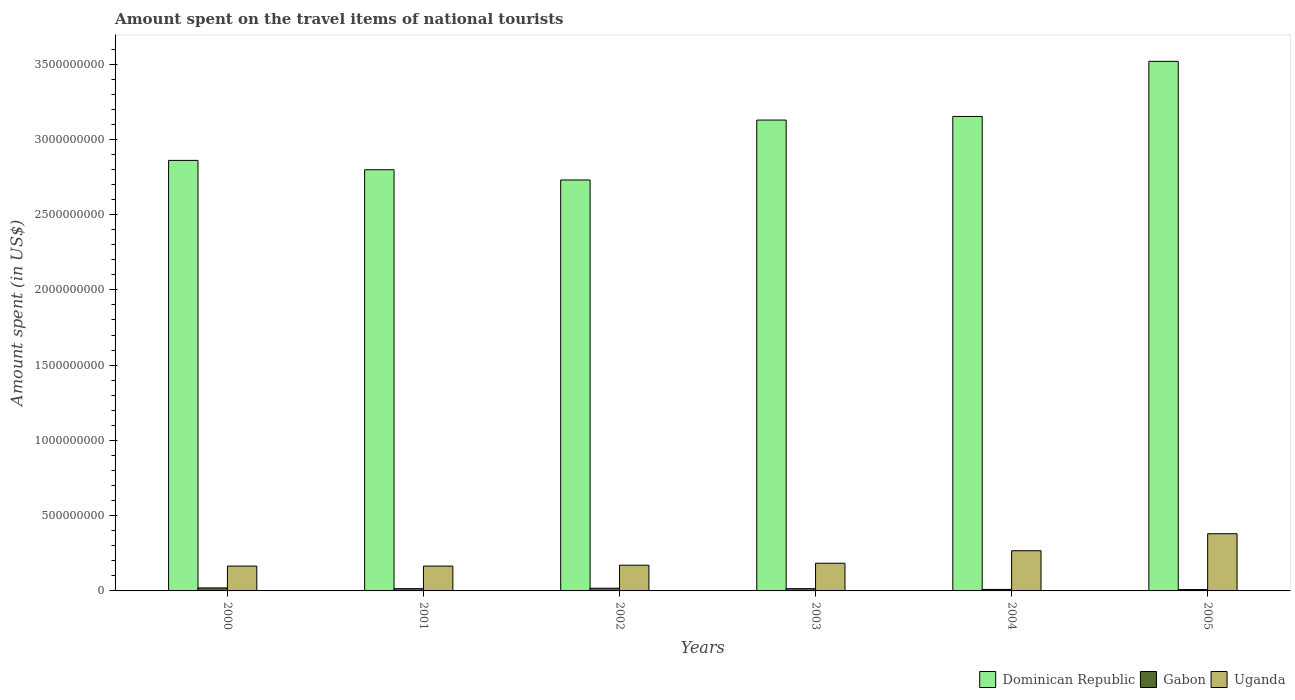How many different coloured bars are there?
Your answer should be compact. 3. How many groups of bars are there?
Your response must be concise. 6. Are the number of bars per tick equal to the number of legend labels?
Give a very brief answer. Yes. Are the number of bars on each tick of the X-axis equal?
Offer a terse response. Yes. How many bars are there on the 2nd tick from the right?
Offer a terse response. 3. What is the label of the 4th group of bars from the left?
Give a very brief answer. 2003. What is the amount spent on the travel items of national tourists in Uganda in 2003?
Give a very brief answer. 1.84e+08. Across all years, what is the maximum amount spent on the travel items of national tourists in Dominican Republic?
Your answer should be very brief. 3.52e+09. Across all years, what is the minimum amount spent on the travel items of national tourists in Dominican Republic?
Provide a short and direct response. 2.73e+09. In which year was the amount spent on the travel items of national tourists in Gabon maximum?
Make the answer very short. 2000. In which year was the amount spent on the travel items of national tourists in Dominican Republic minimum?
Keep it short and to the point. 2002. What is the total amount spent on the travel items of national tourists in Gabon in the graph?
Your response must be concise. 8.70e+07. What is the difference between the amount spent on the travel items of national tourists in Uganda in 2000 and that in 2002?
Give a very brief answer. -6.00e+06. What is the difference between the amount spent on the travel items of national tourists in Dominican Republic in 2003 and the amount spent on the travel items of national tourists in Uganda in 2002?
Your response must be concise. 2.96e+09. What is the average amount spent on the travel items of national tourists in Dominican Republic per year?
Your answer should be very brief. 3.03e+09. In the year 2002, what is the difference between the amount spent on the travel items of national tourists in Dominican Republic and amount spent on the travel items of national tourists in Uganda?
Give a very brief answer. 2.56e+09. What is the difference between the highest and the second highest amount spent on the travel items of national tourists in Gabon?
Ensure brevity in your answer.  2.00e+06. What is the difference between the highest and the lowest amount spent on the travel items of national tourists in Uganda?
Offer a very short reply. 2.15e+08. What does the 2nd bar from the left in 2002 represents?
Provide a short and direct response. Gabon. What does the 3rd bar from the right in 2000 represents?
Offer a very short reply. Dominican Republic. Are all the bars in the graph horizontal?
Ensure brevity in your answer.  No. What is the difference between two consecutive major ticks on the Y-axis?
Keep it short and to the point. 5.00e+08. Does the graph contain any zero values?
Keep it short and to the point. No. Where does the legend appear in the graph?
Provide a succinct answer. Bottom right. How are the legend labels stacked?
Give a very brief answer. Horizontal. What is the title of the graph?
Provide a short and direct response. Amount spent on the travel items of national tourists. Does "Thailand" appear as one of the legend labels in the graph?
Provide a succinct answer. No. What is the label or title of the X-axis?
Your answer should be compact. Years. What is the label or title of the Y-axis?
Keep it short and to the point. Amount spent (in US$). What is the Amount spent (in US$) of Dominican Republic in 2000?
Keep it short and to the point. 2.86e+09. What is the Amount spent (in US$) in Uganda in 2000?
Ensure brevity in your answer.  1.65e+08. What is the Amount spent (in US$) of Dominican Republic in 2001?
Give a very brief answer. 2.80e+09. What is the Amount spent (in US$) in Gabon in 2001?
Provide a short and direct response. 1.50e+07. What is the Amount spent (in US$) of Uganda in 2001?
Keep it short and to the point. 1.65e+08. What is the Amount spent (in US$) of Dominican Republic in 2002?
Make the answer very short. 2.73e+09. What is the Amount spent (in US$) in Gabon in 2002?
Your answer should be very brief. 1.80e+07. What is the Amount spent (in US$) in Uganda in 2002?
Ensure brevity in your answer.  1.71e+08. What is the Amount spent (in US$) of Dominican Republic in 2003?
Your response must be concise. 3.13e+09. What is the Amount spent (in US$) of Gabon in 2003?
Your answer should be compact. 1.50e+07. What is the Amount spent (in US$) of Uganda in 2003?
Your answer should be compact. 1.84e+08. What is the Amount spent (in US$) in Dominican Republic in 2004?
Your answer should be compact. 3.15e+09. What is the Amount spent (in US$) in Uganda in 2004?
Your answer should be compact. 2.67e+08. What is the Amount spent (in US$) of Dominican Republic in 2005?
Give a very brief answer. 3.52e+09. What is the Amount spent (in US$) of Gabon in 2005?
Keep it short and to the point. 9.00e+06. What is the Amount spent (in US$) of Uganda in 2005?
Provide a short and direct response. 3.80e+08. Across all years, what is the maximum Amount spent (in US$) in Dominican Republic?
Your answer should be very brief. 3.52e+09. Across all years, what is the maximum Amount spent (in US$) in Gabon?
Offer a very short reply. 2.00e+07. Across all years, what is the maximum Amount spent (in US$) in Uganda?
Offer a very short reply. 3.80e+08. Across all years, what is the minimum Amount spent (in US$) in Dominican Republic?
Your response must be concise. 2.73e+09. Across all years, what is the minimum Amount spent (in US$) of Gabon?
Provide a short and direct response. 9.00e+06. Across all years, what is the minimum Amount spent (in US$) of Uganda?
Keep it short and to the point. 1.65e+08. What is the total Amount spent (in US$) in Dominican Republic in the graph?
Offer a terse response. 1.82e+1. What is the total Amount spent (in US$) of Gabon in the graph?
Ensure brevity in your answer.  8.70e+07. What is the total Amount spent (in US$) in Uganda in the graph?
Provide a succinct answer. 1.33e+09. What is the difference between the Amount spent (in US$) in Dominican Republic in 2000 and that in 2001?
Ensure brevity in your answer.  6.20e+07. What is the difference between the Amount spent (in US$) in Uganda in 2000 and that in 2001?
Ensure brevity in your answer.  0. What is the difference between the Amount spent (in US$) in Dominican Republic in 2000 and that in 2002?
Give a very brief answer. 1.30e+08. What is the difference between the Amount spent (in US$) in Gabon in 2000 and that in 2002?
Make the answer very short. 2.00e+06. What is the difference between the Amount spent (in US$) in Uganda in 2000 and that in 2002?
Make the answer very short. -6.00e+06. What is the difference between the Amount spent (in US$) of Dominican Republic in 2000 and that in 2003?
Keep it short and to the point. -2.68e+08. What is the difference between the Amount spent (in US$) in Gabon in 2000 and that in 2003?
Your response must be concise. 5.00e+06. What is the difference between the Amount spent (in US$) of Uganda in 2000 and that in 2003?
Give a very brief answer. -1.90e+07. What is the difference between the Amount spent (in US$) in Dominican Republic in 2000 and that in 2004?
Your answer should be very brief. -2.92e+08. What is the difference between the Amount spent (in US$) of Gabon in 2000 and that in 2004?
Make the answer very short. 1.00e+07. What is the difference between the Amount spent (in US$) in Uganda in 2000 and that in 2004?
Ensure brevity in your answer.  -1.02e+08. What is the difference between the Amount spent (in US$) in Dominican Republic in 2000 and that in 2005?
Provide a short and direct response. -6.58e+08. What is the difference between the Amount spent (in US$) of Gabon in 2000 and that in 2005?
Your answer should be very brief. 1.10e+07. What is the difference between the Amount spent (in US$) of Uganda in 2000 and that in 2005?
Your answer should be compact. -2.15e+08. What is the difference between the Amount spent (in US$) in Dominican Republic in 2001 and that in 2002?
Your answer should be very brief. 6.80e+07. What is the difference between the Amount spent (in US$) of Uganda in 2001 and that in 2002?
Keep it short and to the point. -6.00e+06. What is the difference between the Amount spent (in US$) in Dominican Republic in 2001 and that in 2003?
Your answer should be very brief. -3.30e+08. What is the difference between the Amount spent (in US$) of Uganda in 2001 and that in 2003?
Provide a short and direct response. -1.90e+07. What is the difference between the Amount spent (in US$) of Dominican Republic in 2001 and that in 2004?
Offer a very short reply. -3.54e+08. What is the difference between the Amount spent (in US$) in Uganda in 2001 and that in 2004?
Make the answer very short. -1.02e+08. What is the difference between the Amount spent (in US$) of Dominican Republic in 2001 and that in 2005?
Your answer should be compact. -7.20e+08. What is the difference between the Amount spent (in US$) in Uganda in 2001 and that in 2005?
Make the answer very short. -2.15e+08. What is the difference between the Amount spent (in US$) of Dominican Republic in 2002 and that in 2003?
Provide a short and direct response. -3.98e+08. What is the difference between the Amount spent (in US$) in Gabon in 2002 and that in 2003?
Keep it short and to the point. 3.00e+06. What is the difference between the Amount spent (in US$) of Uganda in 2002 and that in 2003?
Your response must be concise. -1.30e+07. What is the difference between the Amount spent (in US$) of Dominican Republic in 2002 and that in 2004?
Keep it short and to the point. -4.22e+08. What is the difference between the Amount spent (in US$) in Uganda in 2002 and that in 2004?
Keep it short and to the point. -9.60e+07. What is the difference between the Amount spent (in US$) of Dominican Republic in 2002 and that in 2005?
Provide a succinct answer. -7.88e+08. What is the difference between the Amount spent (in US$) in Gabon in 2002 and that in 2005?
Offer a very short reply. 9.00e+06. What is the difference between the Amount spent (in US$) of Uganda in 2002 and that in 2005?
Offer a terse response. -2.09e+08. What is the difference between the Amount spent (in US$) in Dominican Republic in 2003 and that in 2004?
Ensure brevity in your answer.  -2.40e+07. What is the difference between the Amount spent (in US$) in Uganda in 2003 and that in 2004?
Offer a terse response. -8.30e+07. What is the difference between the Amount spent (in US$) in Dominican Republic in 2003 and that in 2005?
Make the answer very short. -3.90e+08. What is the difference between the Amount spent (in US$) in Gabon in 2003 and that in 2005?
Ensure brevity in your answer.  6.00e+06. What is the difference between the Amount spent (in US$) of Uganda in 2003 and that in 2005?
Keep it short and to the point. -1.96e+08. What is the difference between the Amount spent (in US$) in Dominican Republic in 2004 and that in 2005?
Provide a succinct answer. -3.66e+08. What is the difference between the Amount spent (in US$) in Uganda in 2004 and that in 2005?
Your answer should be compact. -1.13e+08. What is the difference between the Amount spent (in US$) in Dominican Republic in 2000 and the Amount spent (in US$) in Gabon in 2001?
Provide a succinct answer. 2.84e+09. What is the difference between the Amount spent (in US$) in Dominican Republic in 2000 and the Amount spent (in US$) in Uganda in 2001?
Offer a terse response. 2.70e+09. What is the difference between the Amount spent (in US$) of Gabon in 2000 and the Amount spent (in US$) of Uganda in 2001?
Your response must be concise. -1.45e+08. What is the difference between the Amount spent (in US$) of Dominican Republic in 2000 and the Amount spent (in US$) of Gabon in 2002?
Offer a very short reply. 2.84e+09. What is the difference between the Amount spent (in US$) of Dominican Republic in 2000 and the Amount spent (in US$) of Uganda in 2002?
Your response must be concise. 2.69e+09. What is the difference between the Amount spent (in US$) of Gabon in 2000 and the Amount spent (in US$) of Uganda in 2002?
Ensure brevity in your answer.  -1.51e+08. What is the difference between the Amount spent (in US$) in Dominican Republic in 2000 and the Amount spent (in US$) in Gabon in 2003?
Your response must be concise. 2.84e+09. What is the difference between the Amount spent (in US$) in Dominican Republic in 2000 and the Amount spent (in US$) in Uganda in 2003?
Provide a short and direct response. 2.68e+09. What is the difference between the Amount spent (in US$) of Gabon in 2000 and the Amount spent (in US$) of Uganda in 2003?
Your answer should be very brief. -1.64e+08. What is the difference between the Amount spent (in US$) in Dominican Republic in 2000 and the Amount spent (in US$) in Gabon in 2004?
Your answer should be very brief. 2.85e+09. What is the difference between the Amount spent (in US$) in Dominican Republic in 2000 and the Amount spent (in US$) in Uganda in 2004?
Your answer should be compact. 2.59e+09. What is the difference between the Amount spent (in US$) of Gabon in 2000 and the Amount spent (in US$) of Uganda in 2004?
Keep it short and to the point. -2.47e+08. What is the difference between the Amount spent (in US$) of Dominican Republic in 2000 and the Amount spent (in US$) of Gabon in 2005?
Offer a very short reply. 2.85e+09. What is the difference between the Amount spent (in US$) in Dominican Republic in 2000 and the Amount spent (in US$) in Uganda in 2005?
Offer a very short reply. 2.48e+09. What is the difference between the Amount spent (in US$) in Gabon in 2000 and the Amount spent (in US$) in Uganda in 2005?
Keep it short and to the point. -3.60e+08. What is the difference between the Amount spent (in US$) of Dominican Republic in 2001 and the Amount spent (in US$) of Gabon in 2002?
Keep it short and to the point. 2.78e+09. What is the difference between the Amount spent (in US$) in Dominican Republic in 2001 and the Amount spent (in US$) in Uganda in 2002?
Your answer should be compact. 2.63e+09. What is the difference between the Amount spent (in US$) of Gabon in 2001 and the Amount spent (in US$) of Uganda in 2002?
Give a very brief answer. -1.56e+08. What is the difference between the Amount spent (in US$) of Dominican Republic in 2001 and the Amount spent (in US$) of Gabon in 2003?
Give a very brief answer. 2.78e+09. What is the difference between the Amount spent (in US$) of Dominican Republic in 2001 and the Amount spent (in US$) of Uganda in 2003?
Make the answer very short. 2.61e+09. What is the difference between the Amount spent (in US$) of Gabon in 2001 and the Amount spent (in US$) of Uganda in 2003?
Your answer should be very brief. -1.69e+08. What is the difference between the Amount spent (in US$) of Dominican Republic in 2001 and the Amount spent (in US$) of Gabon in 2004?
Make the answer very short. 2.79e+09. What is the difference between the Amount spent (in US$) in Dominican Republic in 2001 and the Amount spent (in US$) in Uganda in 2004?
Make the answer very short. 2.53e+09. What is the difference between the Amount spent (in US$) of Gabon in 2001 and the Amount spent (in US$) of Uganda in 2004?
Give a very brief answer. -2.52e+08. What is the difference between the Amount spent (in US$) of Dominican Republic in 2001 and the Amount spent (in US$) of Gabon in 2005?
Make the answer very short. 2.79e+09. What is the difference between the Amount spent (in US$) of Dominican Republic in 2001 and the Amount spent (in US$) of Uganda in 2005?
Offer a very short reply. 2.42e+09. What is the difference between the Amount spent (in US$) in Gabon in 2001 and the Amount spent (in US$) in Uganda in 2005?
Offer a terse response. -3.65e+08. What is the difference between the Amount spent (in US$) in Dominican Republic in 2002 and the Amount spent (in US$) in Gabon in 2003?
Provide a succinct answer. 2.72e+09. What is the difference between the Amount spent (in US$) of Dominican Republic in 2002 and the Amount spent (in US$) of Uganda in 2003?
Offer a terse response. 2.55e+09. What is the difference between the Amount spent (in US$) in Gabon in 2002 and the Amount spent (in US$) in Uganda in 2003?
Provide a succinct answer. -1.66e+08. What is the difference between the Amount spent (in US$) of Dominican Republic in 2002 and the Amount spent (in US$) of Gabon in 2004?
Ensure brevity in your answer.  2.72e+09. What is the difference between the Amount spent (in US$) of Dominican Republic in 2002 and the Amount spent (in US$) of Uganda in 2004?
Provide a succinct answer. 2.46e+09. What is the difference between the Amount spent (in US$) in Gabon in 2002 and the Amount spent (in US$) in Uganda in 2004?
Your answer should be very brief. -2.49e+08. What is the difference between the Amount spent (in US$) of Dominican Republic in 2002 and the Amount spent (in US$) of Gabon in 2005?
Keep it short and to the point. 2.72e+09. What is the difference between the Amount spent (in US$) of Dominican Republic in 2002 and the Amount spent (in US$) of Uganda in 2005?
Offer a terse response. 2.35e+09. What is the difference between the Amount spent (in US$) in Gabon in 2002 and the Amount spent (in US$) in Uganda in 2005?
Provide a short and direct response. -3.62e+08. What is the difference between the Amount spent (in US$) of Dominican Republic in 2003 and the Amount spent (in US$) of Gabon in 2004?
Give a very brief answer. 3.12e+09. What is the difference between the Amount spent (in US$) in Dominican Republic in 2003 and the Amount spent (in US$) in Uganda in 2004?
Provide a short and direct response. 2.86e+09. What is the difference between the Amount spent (in US$) in Gabon in 2003 and the Amount spent (in US$) in Uganda in 2004?
Ensure brevity in your answer.  -2.52e+08. What is the difference between the Amount spent (in US$) of Dominican Republic in 2003 and the Amount spent (in US$) of Gabon in 2005?
Provide a short and direct response. 3.12e+09. What is the difference between the Amount spent (in US$) of Dominican Republic in 2003 and the Amount spent (in US$) of Uganda in 2005?
Your answer should be compact. 2.75e+09. What is the difference between the Amount spent (in US$) of Gabon in 2003 and the Amount spent (in US$) of Uganda in 2005?
Make the answer very short. -3.65e+08. What is the difference between the Amount spent (in US$) of Dominican Republic in 2004 and the Amount spent (in US$) of Gabon in 2005?
Make the answer very short. 3.14e+09. What is the difference between the Amount spent (in US$) in Dominican Republic in 2004 and the Amount spent (in US$) in Uganda in 2005?
Give a very brief answer. 2.77e+09. What is the difference between the Amount spent (in US$) in Gabon in 2004 and the Amount spent (in US$) in Uganda in 2005?
Your answer should be very brief. -3.70e+08. What is the average Amount spent (in US$) in Dominican Republic per year?
Your response must be concise. 3.03e+09. What is the average Amount spent (in US$) of Gabon per year?
Your response must be concise. 1.45e+07. What is the average Amount spent (in US$) in Uganda per year?
Your response must be concise. 2.22e+08. In the year 2000, what is the difference between the Amount spent (in US$) of Dominican Republic and Amount spent (in US$) of Gabon?
Ensure brevity in your answer.  2.84e+09. In the year 2000, what is the difference between the Amount spent (in US$) in Dominican Republic and Amount spent (in US$) in Uganda?
Make the answer very short. 2.70e+09. In the year 2000, what is the difference between the Amount spent (in US$) of Gabon and Amount spent (in US$) of Uganda?
Your answer should be very brief. -1.45e+08. In the year 2001, what is the difference between the Amount spent (in US$) of Dominican Republic and Amount spent (in US$) of Gabon?
Provide a short and direct response. 2.78e+09. In the year 2001, what is the difference between the Amount spent (in US$) in Dominican Republic and Amount spent (in US$) in Uganda?
Give a very brief answer. 2.63e+09. In the year 2001, what is the difference between the Amount spent (in US$) of Gabon and Amount spent (in US$) of Uganda?
Your response must be concise. -1.50e+08. In the year 2002, what is the difference between the Amount spent (in US$) of Dominican Republic and Amount spent (in US$) of Gabon?
Your response must be concise. 2.71e+09. In the year 2002, what is the difference between the Amount spent (in US$) in Dominican Republic and Amount spent (in US$) in Uganda?
Provide a succinct answer. 2.56e+09. In the year 2002, what is the difference between the Amount spent (in US$) of Gabon and Amount spent (in US$) of Uganda?
Your answer should be compact. -1.53e+08. In the year 2003, what is the difference between the Amount spent (in US$) of Dominican Republic and Amount spent (in US$) of Gabon?
Your answer should be compact. 3.11e+09. In the year 2003, what is the difference between the Amount spent (in US$) in Dominican Republic and Amount spent (in US$) in Uganda?
Offer a terse response. 2.94e+09. In the year 2003, what is the difference between the Amount spent (in US$) of Gabon and Amount spent (in US$) of Uganda?
Provide a short and direct response. -1.69e+08. In the year 2004, what is the difference between the Amount spent (in US$) in Dominican Republic and Amount spent (in US$) in Gabon?
Your response must be concise. 3.14e+09. In the year 2004, what is the difference between the Amount spent (in US$) in Dominican Republic and Amount spent (in US$) in Uganda?
Offer a terse response. 2.88e+09. In the year 2004, what is the difference between the Amount spent (in US$) of Gabon and Amount spent (in US$) of Uganda?
Your answer should be very brief. -2.57e+08. In the year 2005, what is the difference between the Amount spent (in US$) in Dominican Republic and Amount spent (in US$) in Gabon?
Give a very brief answer. 3.51e+09. In the year 2005, what is the difference between the Amount spent (in US$) of Dominican Republic and Amount spent (in US$) of Uganda?
Ensure brevity in your answer.  3.14e+09. In the year 2005, what is the difference between the Amount spent (in US$) of Gabon and Amount spent (in US$) of Uganda?
Keep it short and to the point. -3.71e+08. What is the ratio of the Amount spent (in US$) of Dominican Republic in 2000 to that in 2001?
Keep it short and to the point. 1.02. What is the ratio of the Amount spent (in US$) in Uganda in 2000 to that in 2001?
Offer a very short reply. 1. What is the ratio of the Amount spent (in US$) of Dominican Republic in 2000 to that in 2002?
Keep it short and to the point. 1.05. What is the ratio of the Amount spent (in US$) of Uganda in 2000 to that in 2002?
Provide a succinct answer. 0.96. What is the ratio of the Amount spent (in US$) in Dominican Republic in 2000 to that in 2003?
Your response must be concise. 0.91. What is the ratio of the Amount spent (in US$) of Uganda in 2000 to that in 2003?
Provide a short and direct response. 0.9. What is the ratio of the Amount spent (in US$) of Dominican Republic in 2000 to that in 2004?
Make the answer very short. 0.91. What is the ratio of the Amount spent (in US$) in Gabon in 2000 to that in 2004?
Make the answer very short. 2. What is the ratio of the Amount spent (in US$) in Uganda in 2000 to that in 2004?
Provide a short and direct response. 0.62. What is the ratio of the Amount spent (in US$) of Dominican Republic in 2000 to that in 2005?
Your answer should be very brief. 0.81. What is the ratio of the Amount spent (in US$) of Gabon in 2000 to that in 2005?
Make the answer very short. 2.22. What is the ratio of the Amount spent (in US$) in Uganda in 2000 to that in 2005?
Give a very brief answer. 0.43. What is the ratio of the Amount spent (in US$) in Dominican Republic in 2001 to that in 2002?
Your answer should be compact. 1.02. What is the ratio of the Amount spent (in US$) in Gabon in 2001 to that in 2002?
Offer a terse response. 0.83. What is the ratio of the Amount spent (in US$) in Uganda in 2001 to that in 2002?
Offer a terse response. 0.96. What is the ratio of the Amount spent (in US$) in Dominican Republic in 2001 to that in 2003?
Your response must be concise. 0.89. What is the ratio of the Amount spent (in US$) of Gabon in 2001 to that in 2003?
Keep it short and to the point. 1. What is the ratio of the Amount spent (in US$) of Uganda in 2001 to that in 2003?
Keep it short and to the point. 0.9. What is the ratio of the Amount spent (in US$) in Dominican Republic in 2001 to that in 2004?
Keep it short and to the point. 0.89. What is the ratio of the Amount spent (in US$) in Uganda in 2001 to that in 2004?
Offer a terse response. 0.62. What is the ratio of the Amount spent (in US$) of Dominican Republic in 2001 to that in 2005?
Provide a short and direct response. 0.8. What is the ratio of the Amount spent (in US$) of Uganda in 2001 to that in 2005?
Your response must be concise. 0.43. What is the ratio of the Amount spent (in US$) in Dominican Republic in 2002 to that in 2003?
Offer a very short reply. 0.87. What is the ratio of the Amount spent (in US$) in Gabon in 2002 to that in 2003?
Your answer should be compact. 1.2. What is the ratio of the Amount spent (in US$) in Uganda in 2002 to that in 2003?
Your answer should be compact. 0.93. What is the ratio of the Amount spent (in US$) of Dominican Republic in 2002 to that in 2004?
Provide a succinct answer. 0.87. What is the ratio of the Amount spent (in US$) of Uganda in 2002 to that in 2004?
Provide a succinct answer. 0.64. What is the ratio of the Amount spent (in US$) in Dominican Republic in 2002 to that in 2005?
Offer a very short reply. 0.78. What is the ratio of the Amount spent (in US$) of Gabon in 2002 to that in 2005?
Provide a short and direct response. 2. What is the ratio of the Amount spent (in US$) of Uganda in 2002 to that in 2005?
Your answer should be very brief. 0.45. What is the ratio of the Amount spent (in US$) in Dominican Republic in 2003 to that in 2004?
Your response must be concise. 0.99. What is the ratio of the Amount spent (in US$) of Uganda in 2003 to that in 2004?
Offer a very short reply. 0.69. What is the ratio of the Amount spent (in US$) in Dominican Republic in 2003 to that in 2005?
Give a very brief answer. 0.89. What is the ratio of the Amount spent (in US$) of Gabon in 2003 to that in 2005?
Offer a very short reply. 1.67. What is the ratio of the Amount spent (in US$) of Uganda in 2003 to that in 2005?
Offer a terse response. 0.48. What is the ratio of the Amount spent (in US$) of Dominican Republic in 2004 to that in 2005?
Provide a short and direct response. 0.9. What is the ratio of the Amount spent (in US$) of Gabon in 2004 to that in 2005?
Your response must be concise. 1.11. What is the ratio of the Amount spent (in US$) of Uganda in 2004 to that in 2005?
Your answer should be very brief. 0.7. What is the difference between the highest and the second highest Amount spent (in US$) of Dominican Republic?
Keep it short and to the point. 3.66e+08. What is the difference between the highest and the second highest Amount spent (in US$) in Uganda?
Give a very brief answer. 1.13e+08. What is the difference between the highest and the lowest Amount spent (in US$) of Dominican Republic?
Offer a very short reply. 7.88e+08. What is the difference between the highest and the lowest Amount spent (in US$) of Gabon?
Ensure brevity in your answer.  1.10e+07. What is the difference between the highest and the lowest Amount spent (in US$) in Uganda?
Your answer should be compact. 2.15e+08. 